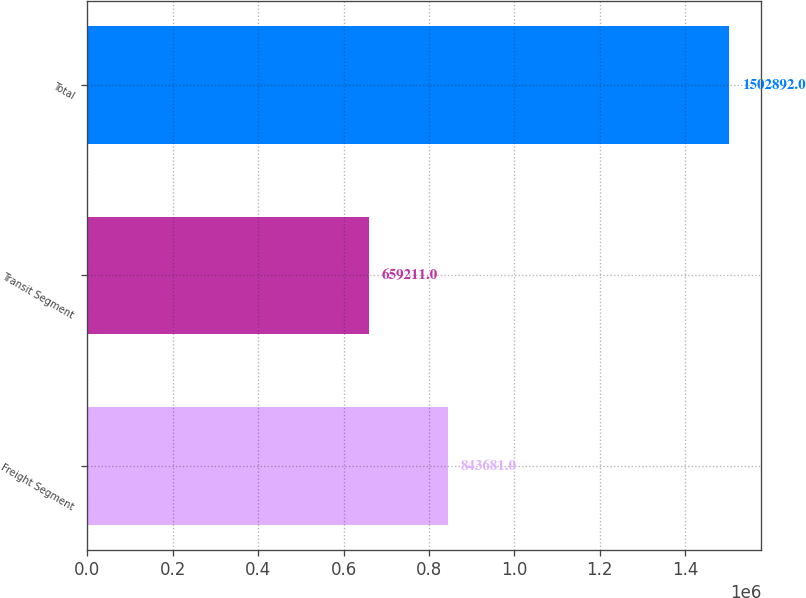<chart> <loc_0><loc_0><loc_500><loc_500><bar_chart><fcel>Freight Segment<fcel>Transit Segment<fcel>Total<nl><fcel>843681<fcel>659211<fcel>1.50289e+06<nl></chart> 